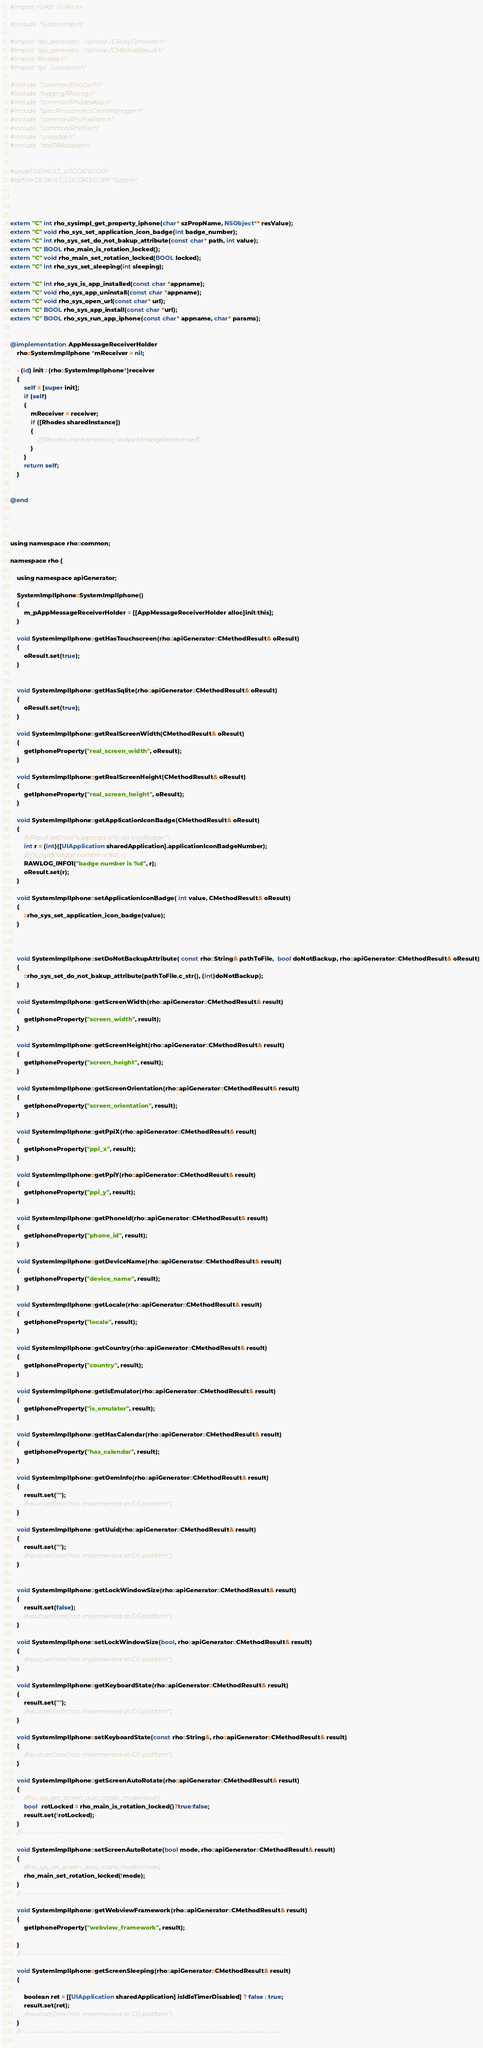Convert code to text. <code><loc_0><loc_0><loc_500><loc_500><_ObjectiveC_>
#import <UIKit/UIKit.h>

#include "SystemImpl.h"

#import "api_generator/iphone/CRubyConverter.h"
#import "api_generator/iphone/CMethodResult.h"
#import "Rhodes.h"
#import "sys/utsname.h"

#include "common/RhoConf.h"
#include "logging/RhoLog.h"
#include "common/RhodesApp.h"
#include "sync/RhoconnectClientManager.h"
#include "common/RhoFilePath.h"
#include "common/RhoFile.h"
#include "unzip/zip.h"
#include "db/DBAdapter.h"


#undef DEFAULT_LOGCATEGORY
#define DEFAULT_LOGCATEGORY "System"




extern "C" int rho_sysimpl_get_property_iphone(char* szPropName, NSObject** resValue);
extern "C" void rho_sys_set_application_icon_badge(int badge_number);
extern "C" int rho_sys_set_do_not_bakup_attribute(const char* path, int value);
extern "C" BOOL rho_main_is_rotation_locked();
extern "C" void rho_main_set_rotation_locked(BOOL locked);
extern "C" int rho_sys_set_sleeping(int sleeping);

extern "C" int rho_sys_is_app_installed(const char *appname);
extern "C" void rho_sys_app_uninstall(const char *appname);
extern "C" void rho_sys_open_url(const char* url);
extern "C" BOOL rho_sys_app_install(const char *url);
extern "C" BOOL rho_sys_run_app_iphone(const char* appname, char* params);


@implementation AppMessageReceiverHolder
    rho::SystemImplIphone *mReceiver = nil;

    - (id) init : (rho::SystemImplIphone*)receiver
    {
        self = [super init];
        if (self)
        {
            mReceiver = receiver;
            if ([Rhodes sharedInstance])
            {
                //[[Rhodes sharedInstance] setAppMessageReceiver:self];
            }
        }
        return self;
    }


@end




using namespace rho::common;

namespace rho {
    
    using namespace apiGenerator;
    
    SystemImplIphone::SystemImplIphone()
    {
        m_pAppMessageReceiverHolder = [[AppMessageReceiverHolder alloc]init:this];
    }
    
    void SystemImplIphone::getHasTouchscreen(rho::apiGenerator::CMethodResult& oResult)
    {
        oResult.set(true);
    }
    
    
    void SystemImplIphone::getHasSqlite(rho::apiGenerator::CMethodResult& oResult)
    {
        oResult.set(true);
    }
    
    void SystemImplIphone::getRealScreenWidth(CMethodResult& oResult)
    {
        getIphoneProperty("real_screen_width", oResult);
    }
    
    void SystemImplIphone::getRealScreenHeight(CMethodResult& oResult)
    {
        getIphoneProperty("real_screen_height", oResult);
    }
    
    void SystemImplIphone::getApplicationIconBadge(CMethodResult& oResult)
    {
        //oResult.setError("supported only set IconBadge !");
        int r = (int)([UIApplication sharedApplication].applicationIconBadgeNumber);
        //NSLog(@"badge number is %d", r);
        RAWLOG_INFO1("badge number is %d", r);
        oResult.set(r);
    }
    
    void SystemImplIphone::setApplicationIconBadge( int value, CMethodResult& oResult)
    {
        ::rho_sys_set_application_icon_badge(value);
    }
    
    
    
    void SystemImplIphone::setDoNotBackupAttribute( const rho::String& pathToFile,  bool doNotBackup, rho::apiGenerator::CMethodResult& oResult)
    {
        ::rho_sys_set_do_not_bakup_attribute(pathToFile.c_str(), (int)doNotBackup);
    }
    
    void SystemImplIphone::getScreenWidth(rho::apiGenerator::CMethodResult& result)
    {
        getIphoneProperty("screen_width", result);
    }
    
    void SystemImplIphone::getScreenHeight(rho::apiGenerator::CMethodResult& result)
    {
        getIphoneProperty("screen_height", result);
    }
    
    void SystemImplIphone::getScreenOrientation(rho::apiGenerator::CMethodResult& result)
    {
        getIphoneProperty("screen_orientation", result);
    }
    
    void SystemImplIphone::getPpiX(rho::apiGenerator::CMethodResult& result)
    {
        getIphoneProperty("ppi_x", result);
    }
    
    void SystemImplIphone::getPpiY(rho::apiGenerator::CMethodResult& result)
    {
        getIphoneProperty("ppi_y", result);
    }
    
    void SystemImplIphone::getPhoneId(rho::apiGenerator::CMethodResult& result)
    {
        getIphoneProperty("phone_id", result);
    }
    
    void SystemImplIphone::getDeviceName(rho::apiGenerator::CMethodResult& result)
    {
        getIphoneProperty("device_name", result);
    }
    
    void SystemImplIphone::getLocale(rho::apiGenerator::CMethodResult& result)
    {
        getIphoneProperty("locale", result);
    }
    
    void SystemImplIphone::getCountry(rho::apiGenerator::CMethodResult& result)
    {
        getIphoneProperty("country", result);
    }
    
    void SystemImplIphone::getIsEmulator(rho::apiGenerator::CMethodResult& result)
    {
        getIphoneProperty("is_emulator", result);
    }
    
    void SystemImplIphone::getHasCalendar(rho::apiGenerator::CMethodResult& result)
    {
        getIphoneProperty("has_calendar", result);
    }
    
    void SystemImplIphone::getOemInfo(rho::apiGenerator::CMethodResult& result)
    {
        result.set("");
        //result.setError("not implemented at iOS platform");
    }
    
    void SystemImplIphone::getUuid(rho::apiGenerator::CMethodResult& result)
    {
        result.set("");
        //result.setError("not implemented at iOS platform");
    }
    
    
    void SystemImplIphone::getLockWindowSize(rho::apiGenerator::CMethodResult& result)
    {
        result.set(false);
        //result.setError("not implemented at iOS platform");
    }
    
    void SystemImplIphone::setLockWindowSize(bool, rho::apiGenerator::CMethodResult& result)
    {
        //result.setError("not implemented at iOS platform");
    }
    
    void SystemImplIphone::getKeyboardState(rho::apiGenerator::CMethodResult& result)
    {
        result.set("");
        //result.setError("not implemented at iOS platform");
    }
    
    void SystemImplIphone::setKeyboardState(const rho::String&, rho::apiGenerator::CMethodResult& result)
    {
        //result.setError("not implemented at iOS platform");
    }
    
    void SystemImplIphone::getScreenAutoRotate(rho::apiGenerator::CMethodResult& result)
    {
        //rho_sys_get_screen_auto_rotate_mode(result);
        bool  rotLocked = rho_main_is_rotation_locked()?true:false;
        result.set(!rotLocked);
    }
    //----------------------------------------------------------------------------------------------------------------------
    
    void SystemImplIphone::setScreenAutoRotate(bool mode, rho::apiGenerator::CMethodResult& result)
    {
        //rho_sys_set_screen_auto_rotate_mode(mode);
        rho_main_set_rotation_locked(!mode);
    }
    //----------------------------------------------------------------------------------------------------------------------
    
    void SystemImplIphone::getWebviewFramework(rho::apiGenerator::CMethodResult& result)
    {
        getIphoneProperty("webview_framework", result);
        
    }
    //----------------------------------------------------------------------------------------------------------------------
    
    void SystemImplIphone::getScreenSleeping(rho::apiGenerator::CMethodResult& result)
    {
        
        boolean ret = [[UIApplication sharedApplication] isIdleTimerDisabled] ? false : true;
        result.set(ret);
        //result.setError("not implemented at iOS platform");
    }
    //----------------------------------------------------------------------------------------------------------------------
    </code> 